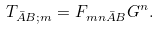<formula> <loc_0><loc_0><loc_500><loc_500>T _ { \bar { A } B ; m } = F _ { m n \bar { A } B } G ^ { n } .</formula> 